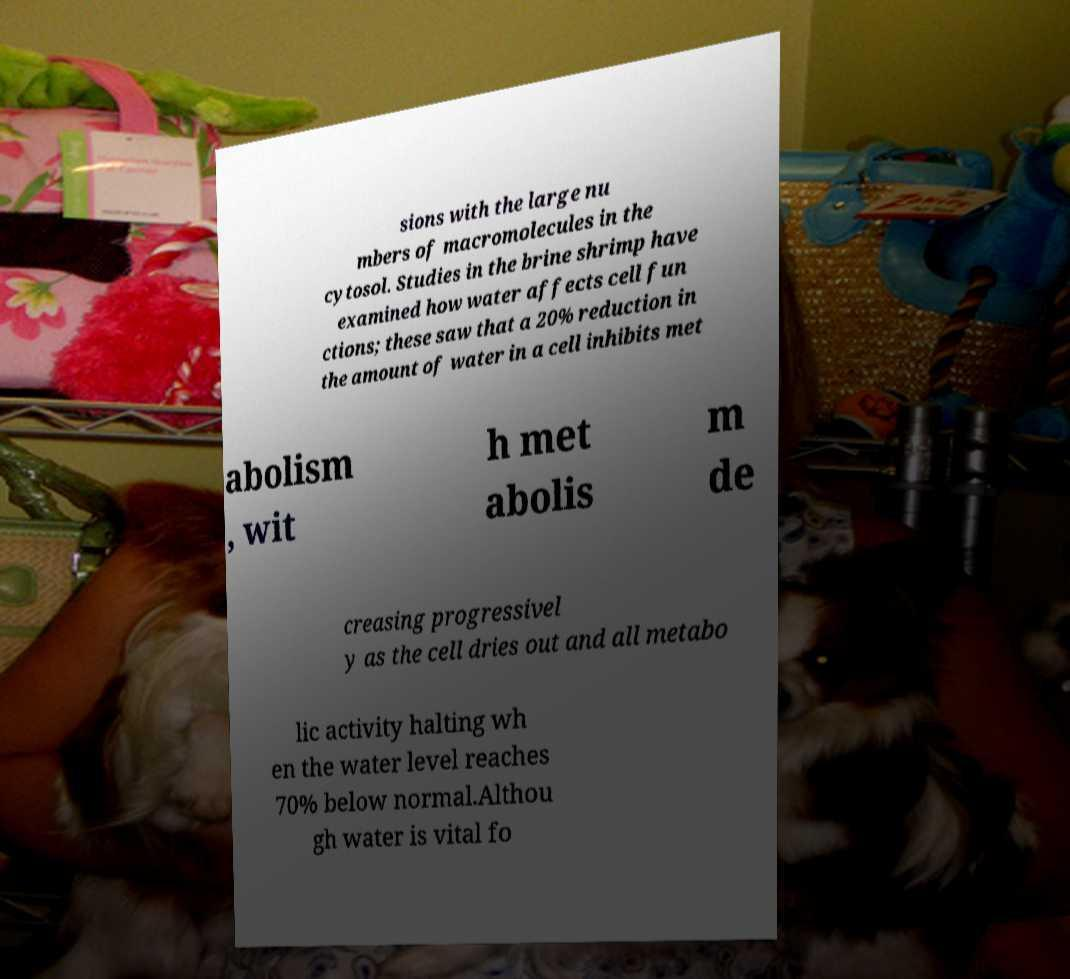For documentation purposes, I need the text within this image transcribed. Could you provide that? sions with the large nu mbers of macromolecules in the cytosol. Studies in the brine shrimp have examined how water affects cell fun ctions; these saw that a 20% reduction in the amount of water in a cell inhibits met abolism , wit h met abolis m de creasing progressivel y as the cell dries out and all metabo lic activity halting wh en the water level reaches 70% below normal.Althou gh water is vital fo 